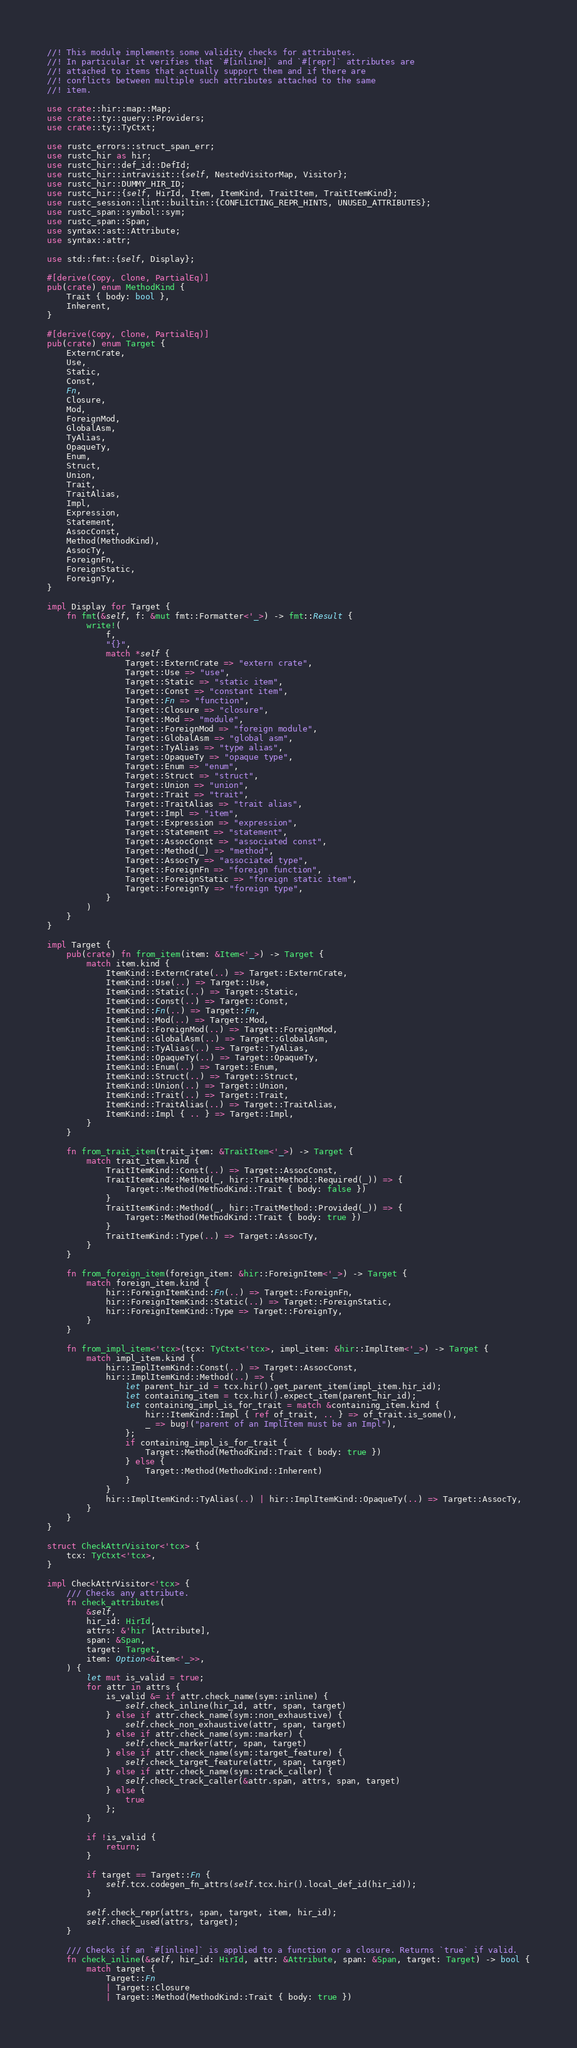Convert code to text. <code><loc_0><loc_0><loc_500><loc_500><_Rust_>//! This module implements some validity checks for attributes.
//! In particular it verifies that `#[inline]` and `#[repr]` attributes are
//! attached to items that actually support them and if there are
//! conflicts between multiple such attributes attached to the same
//! item.

use crate::hir::map::Map;
use crate::ty::query::Providers;
use crate::ty::TyCtxt;

use rustc_errors::struct_span_err;
use rustc_hir as hir;
use rustc_hir::def_id::DefId;
use rustc_hir::intravisit::{self, NestedVisitorMap, Visitor};
use rustc_hir::DUMMY_HIR_ID;
use rustc_hir::{self, HirId, Item, ItemKind, TraitItem, TraitItemKind};
use rustc_session::lint::builtin::{CONFLICTING_REPR_HINTS, UNUSED_ATTRIBUTES};
use rustc_span::symbol::sym;
use rustc_span::Span;
use syntax::ast::Attribute;
use syntax::attr;

use std::fmt::{self, Display};

#[derive(Copy, Clone, PartialEq)]
pub(crate) enum MethodKind {
    Trait { body: bool },
    Inherent,
}

#[derive(Copy, Clone, PartialEq)]
pub(crate) enum Target {
    ExternCrate,
    Use,
    Static,
    Const,
    Fn,
    Closure,
    Mod,
    ForeignMod,
    GlobalAsm,
    TyAlias,
    OpaqueTy,
    Enum,
    Struct,
    Union,
    Trait,
    TraitAlias,
    Impl,
    Expression,
    Statement,
    AssocConst,
    Method(MethodKind),
    AssocTy,
    ForeignFn,
    ForeignStatic,
    ForeignTy,
}

impl Display for Target {
    fn fmt(&self, f: &mut fmt::Formatter<'_>) -> fmt::Result {
        write!(
            f,
            "{}",
            match *self {
                Target::ExternCrate => "extern crate",
                Target::Use => "use",
                Target::Static => "static item",
                Target::Const => "constant item",
                Target::Fn => "function",
                Target::Closure => "closure",
                Target::Mod => "module",
                Target::ForeignMod => "foreign module",
                Target::GlobalAsm => "global asm",
                Target::TyAlias => "type alias",
                Target::OpaqueTy => "opaque type",
                Target::Enum => "enum",
                Target::Struct => "struct",
                Target::Union => "union",
                Target::Trait => "trait",
                Target::TraitAlias => "trait alias",
                Target::Impl => "item",
                Target::Expression => "expression",
                Target::Statement => "statement",
                Target::AssocConst => "associated const",
                Target::Method(_) => "method",
                Target::AssocTy => "associated type",
                Target::ForeignFn => "foreign function",
                Target::ForeignStatic => "foreign static item",
                Target::ForeignTy => "foreign type",
            }
        )
    }
}

impl Target {
    pub(crate) fn from_item(item: &Item<'_>) -> Target {
        match item.kind {
            ItemKind::ExternCrate(..) => Target::ExternCrate,
            ItemKind::Use(..) => Target::Use,
            ItemKind::Static(..) => Target::Static,
            ItemKind::Const(..) => Target::Const,
            ItemKind::Fn(..) => Target::Fn,
            ItemKind::Mod(..) => Target::Mod,
            ItemKind::ForeignMod(..) => Target::ForeignMod,
            ItemKind::GlobalAsm(..) => Target::GlobalAsm,
            ItemKind::TyAlias(..) => Target::TyAlias,
            ItemKind::OpaqueTy(..) => Target::OpaqueTy,
            ItemKind::Enum(..) => Target::Enum,
            ItemKind::Struct(..) => Target::Struct,
            ItemKind::Union(..) => Target::Union,
            ItemKind::Trait(..) => Target::Trait,
            ItemKind::TraitAlias(..) => Target::TraitAlias,
            ItemKind::Impl { .. } => Target::Impl,
        }
    }

    fn from_trait_item(trait_item: &TraitItem<'_>) -> Target {
        match trait_item.kind {
            TraitItemKind::Const(..) => Target::AssocConst,
            TraitItemKind::Method(_, hir::TraitMethod::Required(_)) => {
                Target::Method(MethodKind::Trait { body: false })
            }
            TraitItemKind::Method(_, hir::TraitMethod::Provided(_)) => {
                Target::Method(MethodKind::Trait { body: true })
            }
            TraitItemKind::Type(..) => Target::AssocTy,
        }
    }

    fn from_foreign_item(foreign_item: &hir::ForeignItem<'_>) -> Target {
        match foreign_item.kind {
            hir::ForeignItemKind::Fn(..) => Target::ForeignFn,
            hir::ForeignItemKind::Static(..) => Target::ForeignStatic,
            hir::ForeignItemKind::Type => Target::ForeignTy,
        }
    }

    fn from_impl_item<'tcx>(tcx: TyCtxt<'tcx>, impl_item: &hir::ImplItem<'_>) -> Target {
        match impl_item.kind {
            hir::ImplItemKind::Const(..) => Target::AssocConst,
            hir::ImplItemKind::Method(..) => {
                let parent_hir_id = tcx.hir().get_parent_item(impl_item.hir_id);
                let containing_item = tcx.hir().expect_item(parent_hir_id);
                let containing_impl_is_for_trait = match &containing_item.kind {
                    hir::ItemKind::Impl { ref of_trait, .. } => of_trait.is_some(),
                    _ => bug!("parent of an ImplItem must be an Impl"),
                };
                if containing_impl_is_for_trait {
                    Target::Method(MethodKind::Trait { body: true })
                } else {
                    Target::Method(MethodKind::Inherent)
                }
            }
            hir::ImplItemKind::TyAlias(..) | hir::ImplItemKind::OpaqueTy(..) => Target::AssocTy,
        }
    }
}

struct CheckAttrVisitor<'tcx> {
    tcx: TyCtxt<'tcx>,
}

impl CheckAttrVisitor<'tcx> {
    /// Checks any attribute.
    fn check_attributes(
        &self,
        hir_id: HirId,
        attrs: &'hir [Attribute],
        span: &Span,
        target: Target,
        item: Option<&Item<'_>>,
    ) {
        let mut is_valid = true;
        for attr in attrs {
            is_valid &= if attr.check_name(sym::inline) {
                self.check_inline(hir_id, attr, span, target)
            } else if attr.check_name(sym::non_exhaustive) {
                self.check_non_exhaustive(attr, span, target)
            } else if attr.check_name(sym::marker) {
                self.check_marker(attr, span, target)
            } else if attr.check_name(sym::target_feature) {
                self.check_target_feature(attr, span, target)
            } else if attr.check_name(sym::track_caller) {
                self.check_track_caller(&attr.span, attrs, span, target)
            } else {
                true
            };
        }

        if !is_valid {
            return;
        }

        if target == Target::Fn {
            self.tcx.codegen_fn_attrs(self.tcx.hir().local_def_id(hir_id));
        }

        self.check_repr(attrs, span, target, item, hir_id);
        self.check_used(attrs, target);
    }

    /// Checks if an `#[inline]` is applied to a function or a closure. Returns `true` if valid.
    fn check_inline(&self, hir_id: HirId, attr: &Attribute, span: &Span, target: Target) -> bool {
        match target {
            Target::Fn
            | Target::Closure
            | Target::Method(MethodKind::Trait { body: true })</code> 